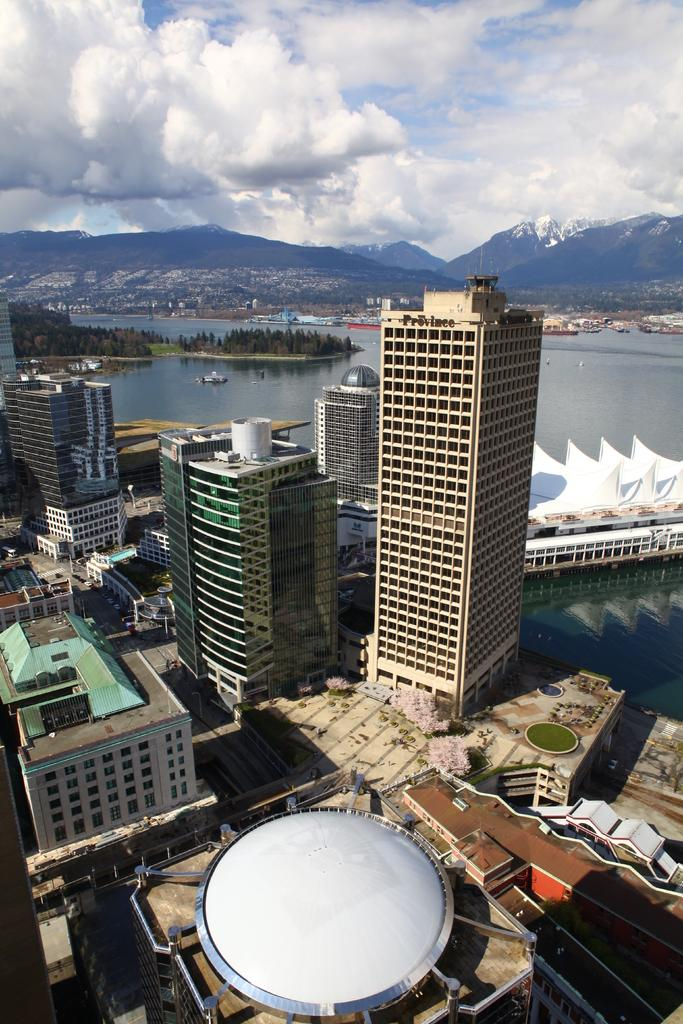What type of structures can be seen in the image? There are buildings in the image. What type of vehicles are present in the image? There are boats in the image. What natural feature is visible in the image? There is water visible in the image. What type of vegetation can be seen in the image? There are trees in the image. What type of geographical feature is present in the image? There are hills in the image. What is visible in the sky in the image? The sky is visible in the image, and clouds are present. What type of bun is being used to hold the watch in the image? There is no bun or watch present in the image. How many bags are visible in the image? There are no bags visible in the image. 